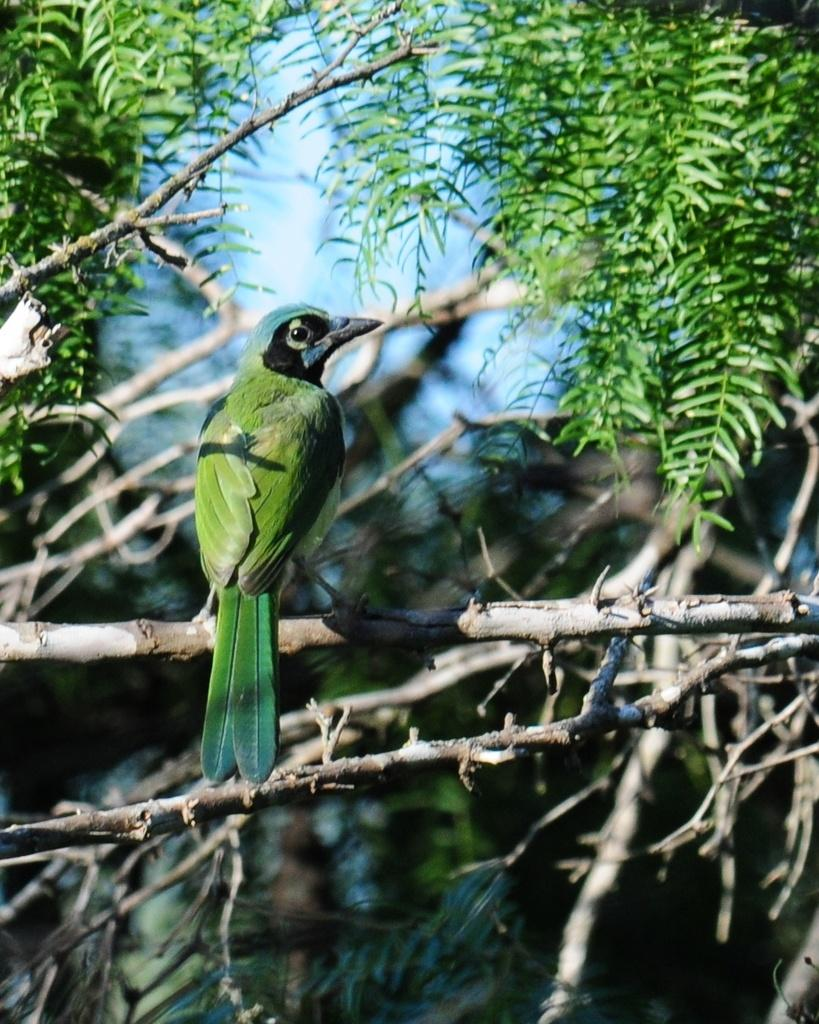What type of animal can be seen in the image? There is a bird in the image. Where is the bird located? The bird is on a stem in the image. What other natural elements are present in the image? There are trees in the image. What can be seen in the background of the image? The sky is visible in the background of the image. How many snails can be seen crawling on the bird in the image? There are no snails present in the image; it features a bird on a stem with trees and the sky in the background. 